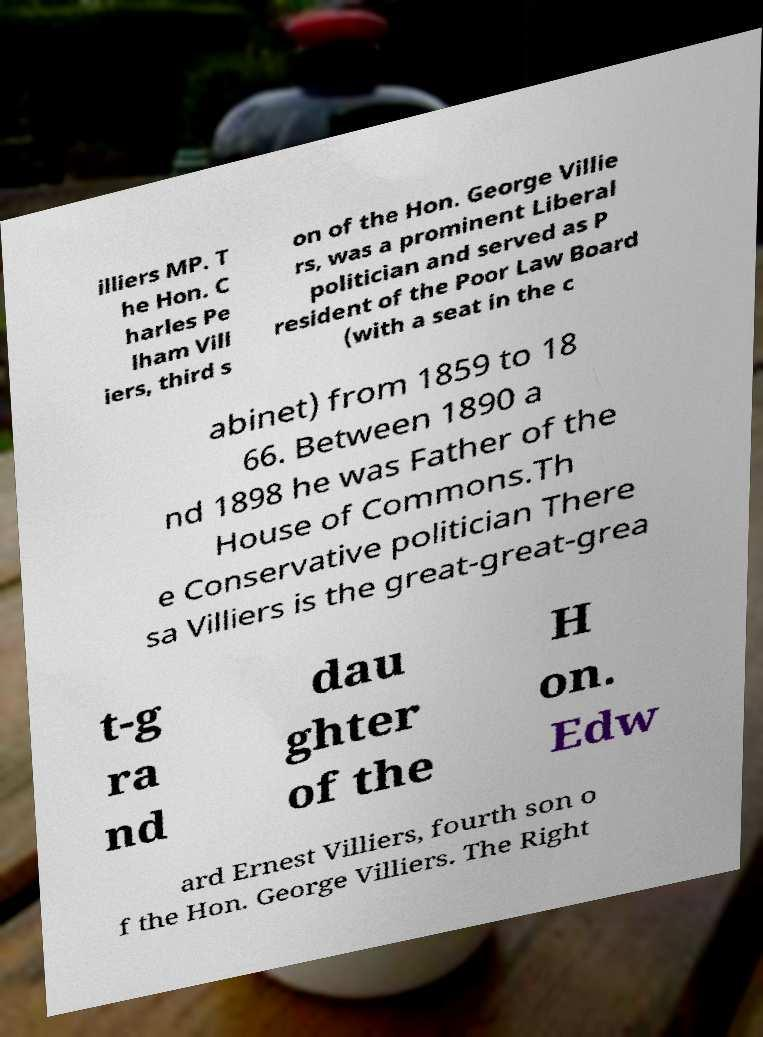For documentation purposes, I need the text within this image transcribed. Could you provide that? illiers MP. T he Hon. C harles Pe lham Vill iers, third s on of the Hon. George Villie rs, was a prominent Liberal politician and served as P resident of the Poor Law Board (with a seat in the c abinet) from 1859 to 18 66. Between 1890 a nd 1898 he was Father of the House of Commons.Th e Conservative politician There sa Villiers is the great-great-grea t-g ra nd dau ghter of the H on. Edw ard Ernest Villiers, fourth son o f the Hon. George Villiers. The Right 